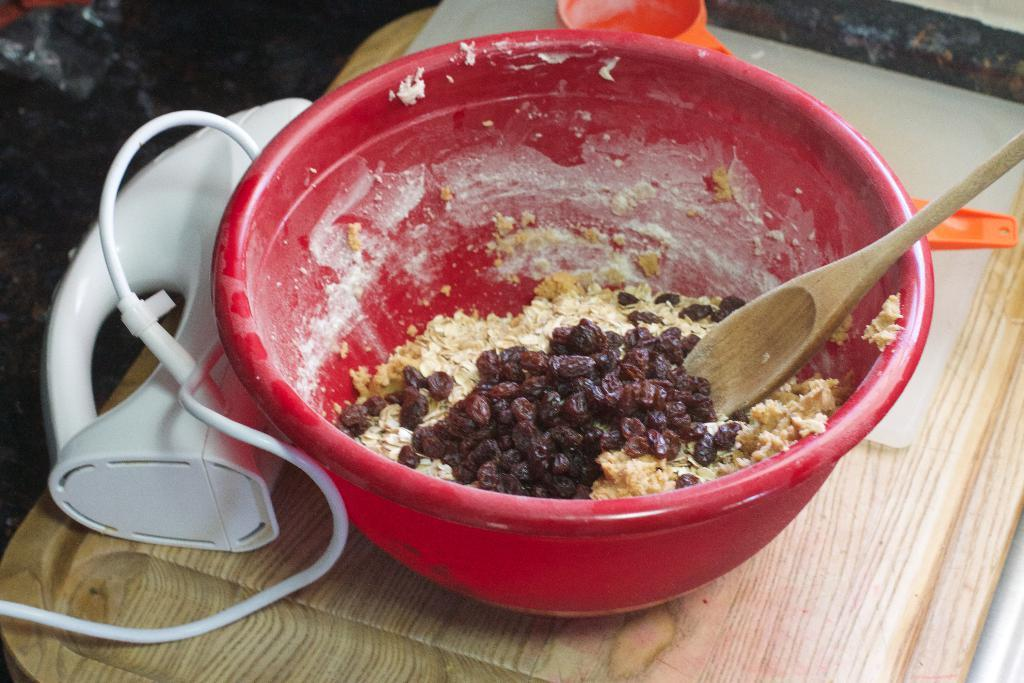What is in the bowl that is visible in the image? There is food in a bowl in the image. What utensil is used with the food in the bowl? There is a spoon in the bowl. What is on the plate in the image? There are objects on a plate in the image. How many plates are on the surface in the image? There are two plates on a surface in the image. What else can be seen on the surface in the image? There are objects on the surface in the image. What type of tank is visible in the image? There is no tank present in the image. What is the interest rate of the loan mentioned in the image? There is no mention of a loan or interest rate in the image. 